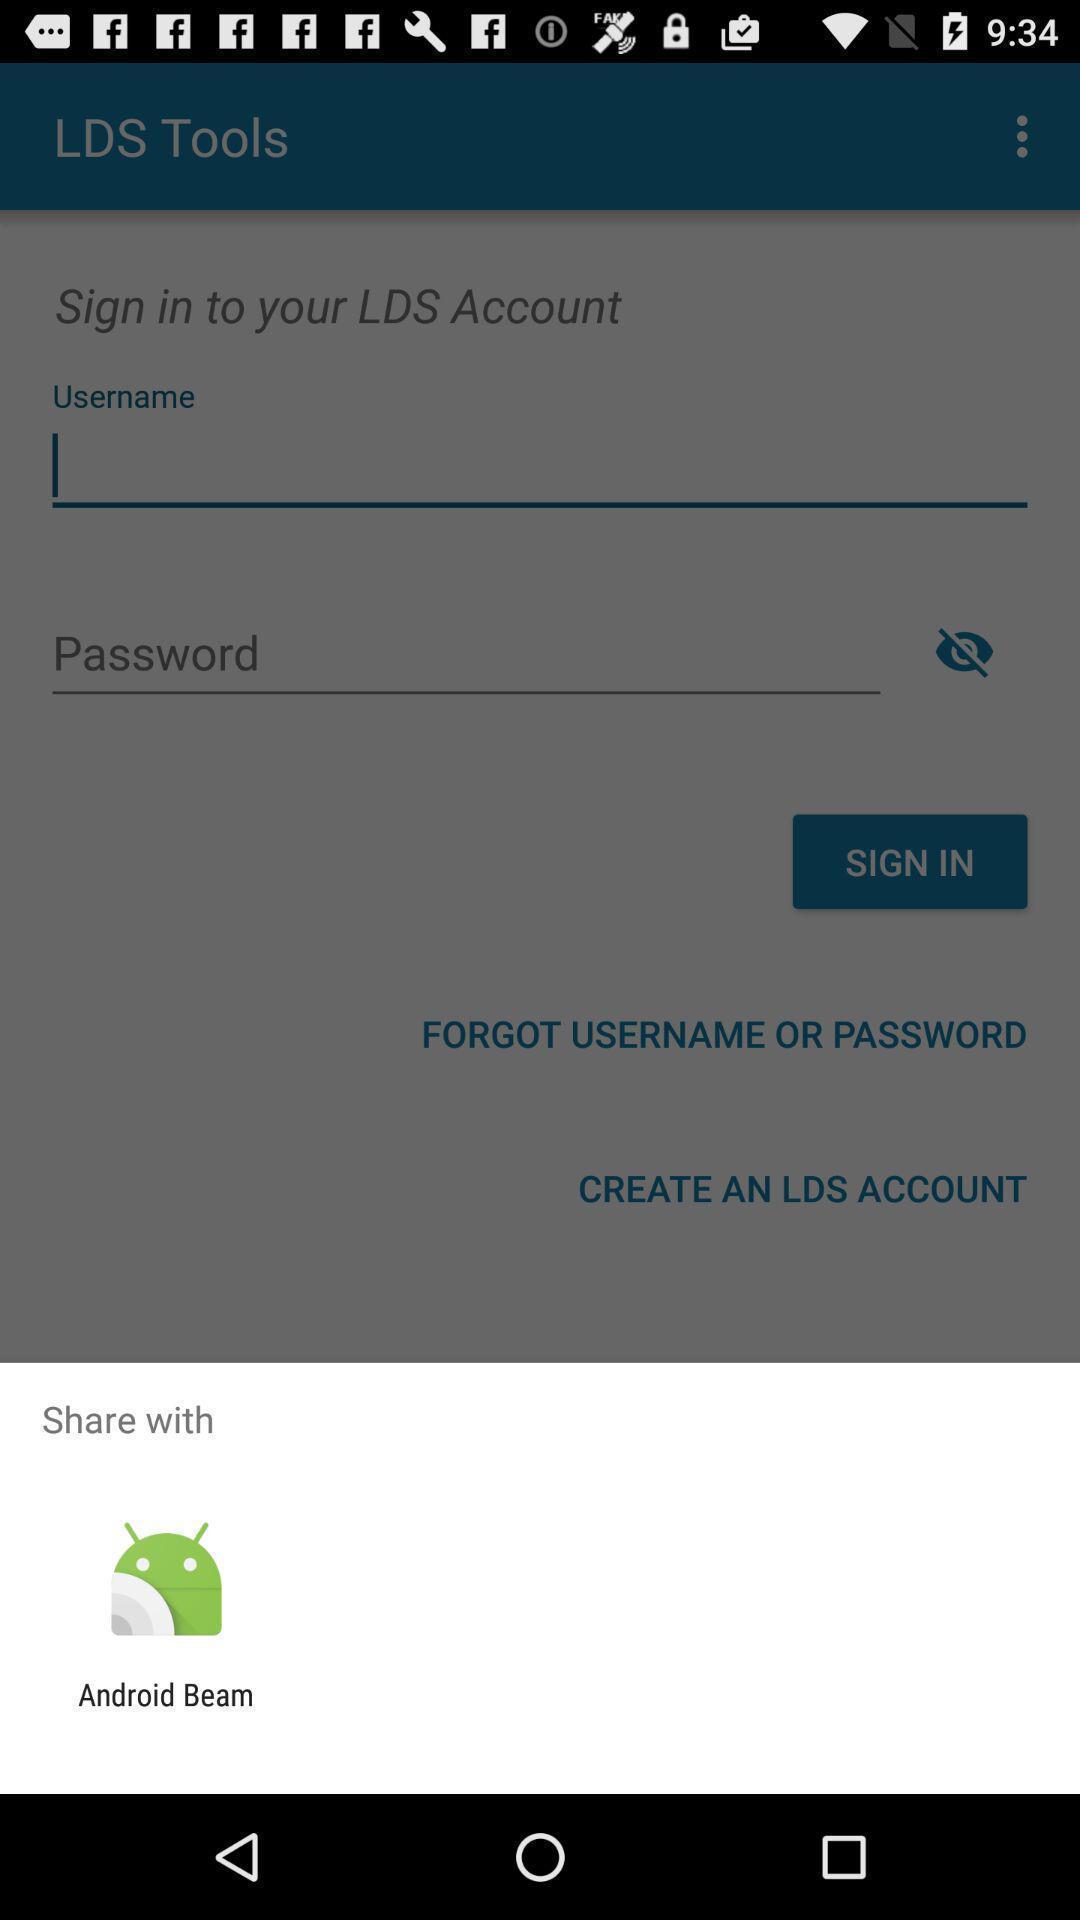What details can you identify in this image? Share with page of a church membership app. 